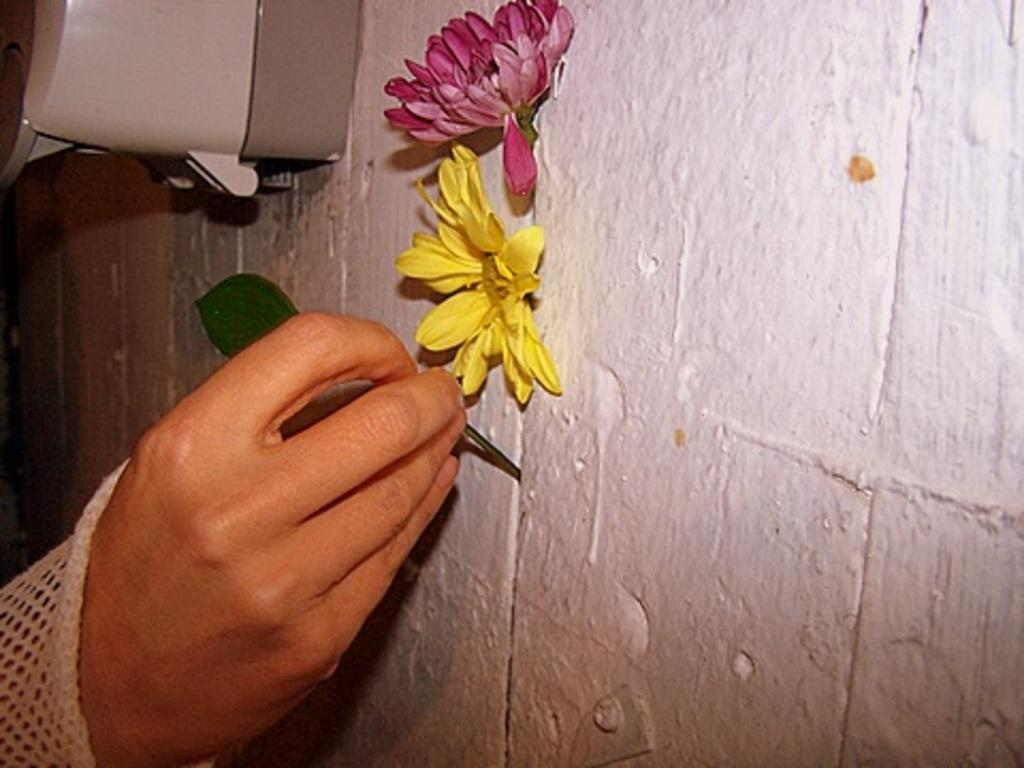What is the main subject in the center of the image? There are flowers on a wall in the center of the image. What can be seen on the left side of the image? There is a person's hand holding a leaf on the left side of the image. What is located at the top of the image? There is a machine visible at the top of the image. How many frogs are sitting on the machine at the top of the image? There are no frogs present in the image; it only features flowers, a hand holding a leaf, and a machine. What is the person's belief about the flowers on the wall? The image does not provide any information about the person's beliefs, so we cannot determine their belief about the flowers on the wall. 